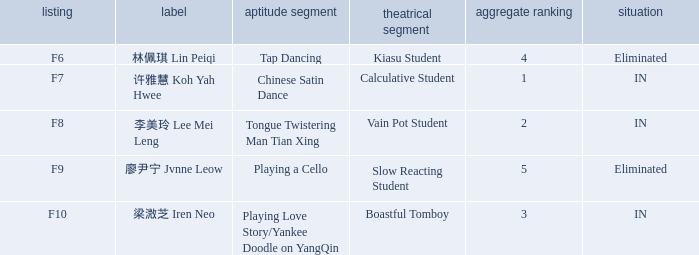For all events with index f10, what is the sum of the overall rankings? 3.0. 